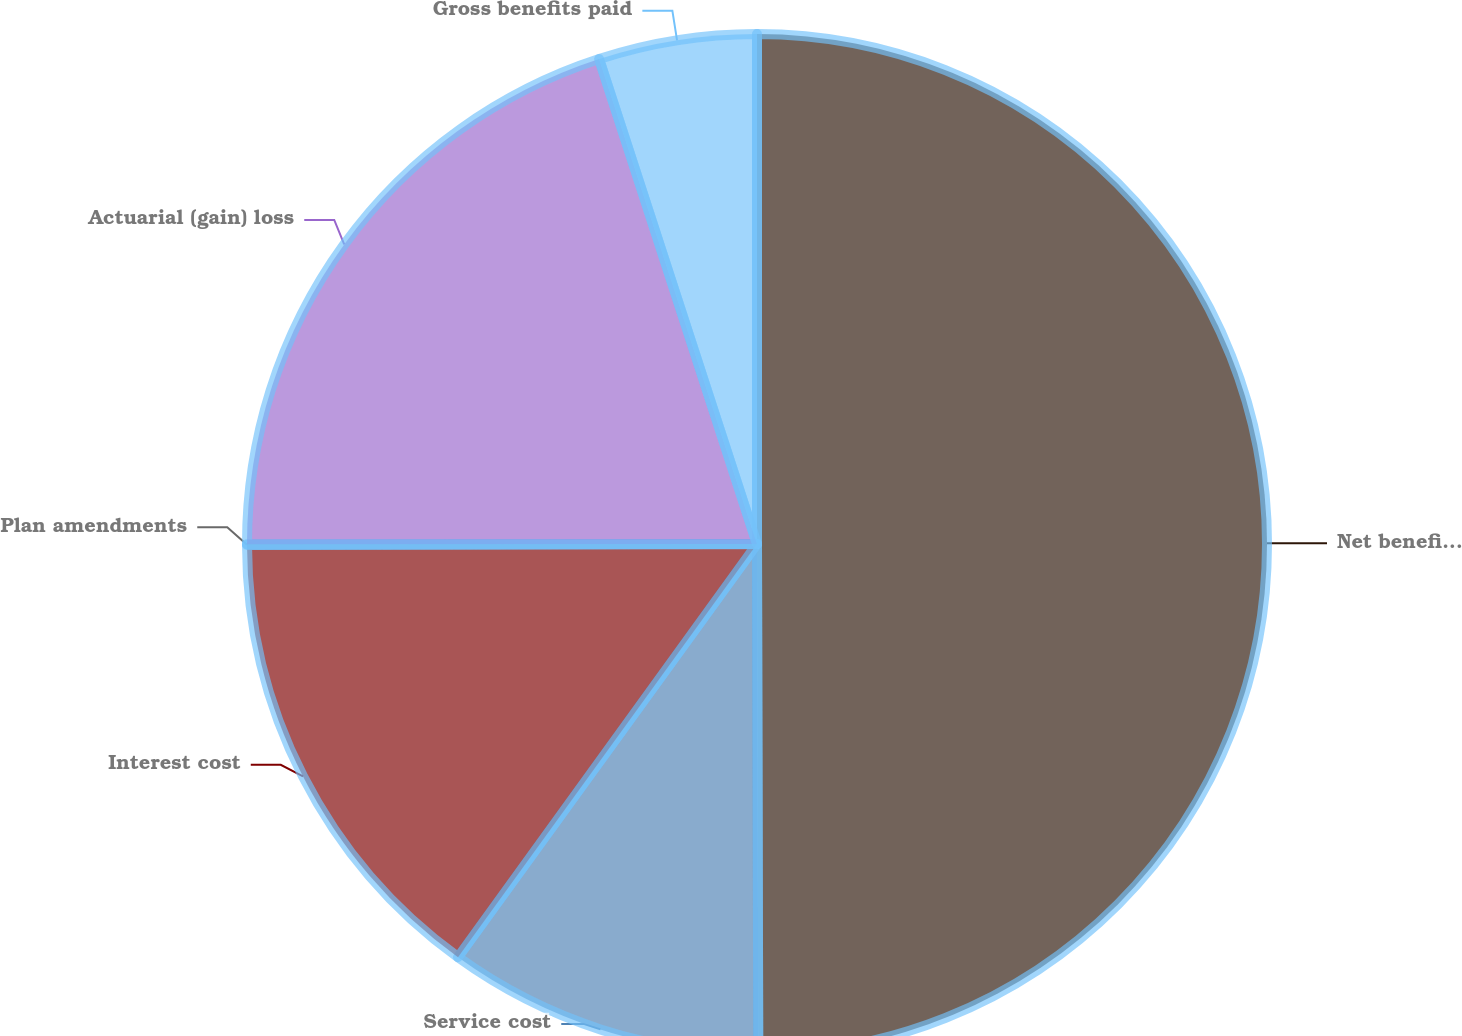Convert chart to OTSL. <chart><loc_0><loc_0><loc_500><loc_500><pie_chart><fcel>Net benefit obligation at<fcel>Service cost<fcel>Interest cost<fcel>Plan amendments<fcel>Actuarial (gain) loss<fcel>Gross benefits paid<nl><fcel>49.96%<fcel>10.01%<fcel>15.0%<fcel>0.02%<fcel>20.0%<fcel>5.01%<nl></chart> 